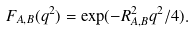Convert formula to latex. <formula><loc_0><loc_0><loc_500><loc_500>F _ { A , B } ( q ^ { 2 } ) = \exp ( - R _ { A , B } ^ { 2 } q ^ { 2 } / 4 ) .</formula> 